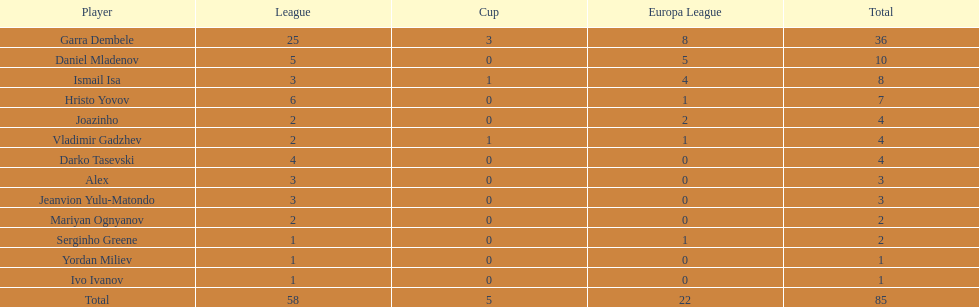How many of the players did not score any goals in the cup? 10. 